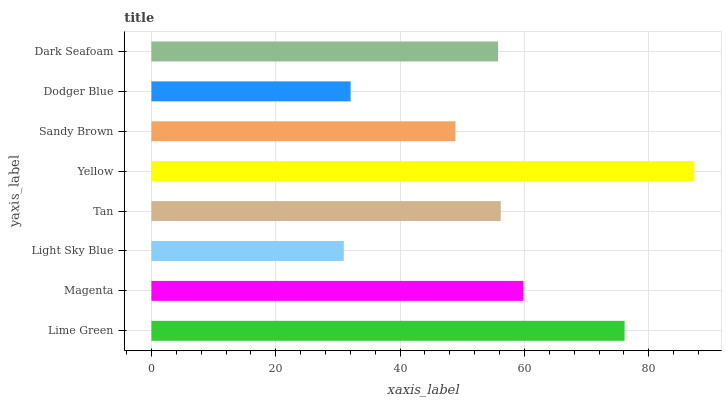Is Light Sky Blue the minimum?
Answer yes or no. Yes. Is Yellow the maximum?
Answer yes or no. Yes. Is Magenta the minimum?
Answer yes or no. No. Is Magenta the maximum?
Answer yes or no. No. Is Lime Green greater than Magenta?
Answer yes or no. Yes. Is Magenta less than Lime Green?
Answer yes or no. Yes. Is Magenta greater than Lime Green?
Answer yes or no. No. Is Lime Green less than Magenta?
Answer yes or no. No. Is Tan the high median?
Answer yes or no. Yes. Is Dark Seafoam the low median?
Answer yes or no. Yes. Is Yellow the high median?
Answer yes or no. No. Is Dodger Blue the low median?
Answer yes or no. No. 